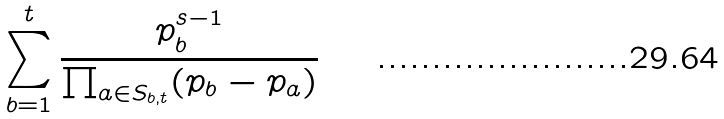<formula> <loc_0><loc_0><loc_500><loc_500>\sum _ { b = 1 } ^ { t } \frac { p _ { b } ^ { s - 1 } } { \prod _ { a \in S _ { b , t } } ( p _ { b } - p _ { a } ) }</formula> 